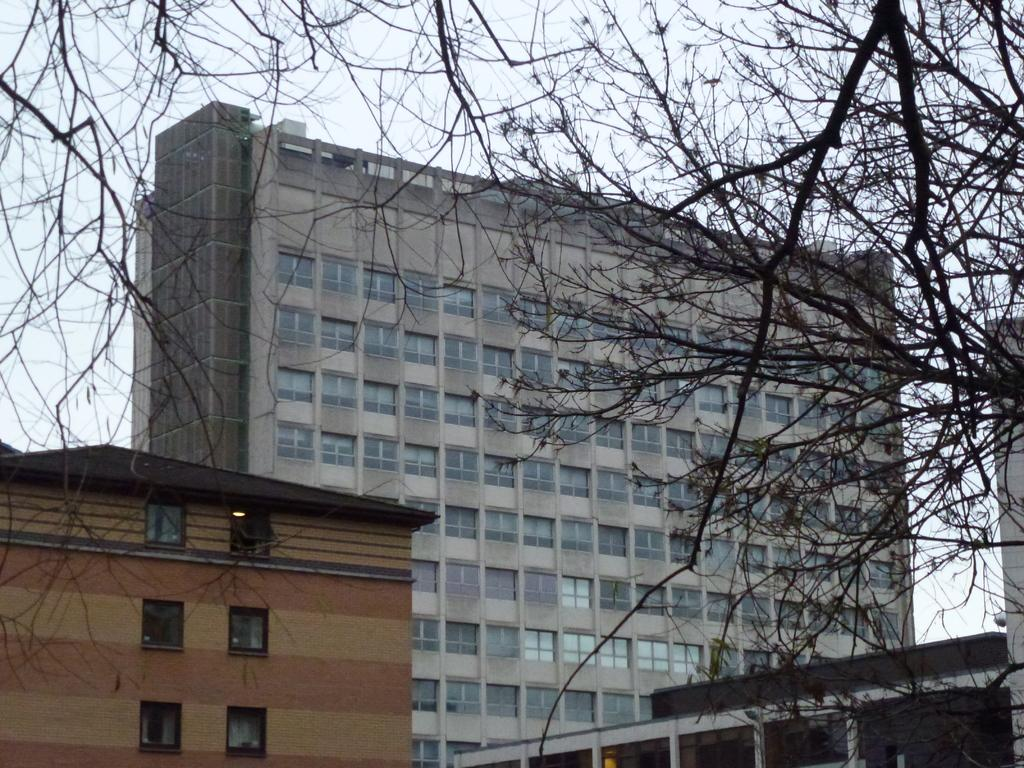What type of structures can be seen in the image? There are buildings in the image. What feature can be found on the buildings? There are windows in the image. What type of vegetation is present in the image? There are trees in the image. What is visible at the top of the image? The sky is visible at the top of the image. Are there any amusement parks visible in the image? There is no indication of an amusement park in the image; it features buildings, windows, trees, and the sky. What time of day is depicted in the image? The time of day cannot be determined from the image, as there are no specific clues or indicators present. 